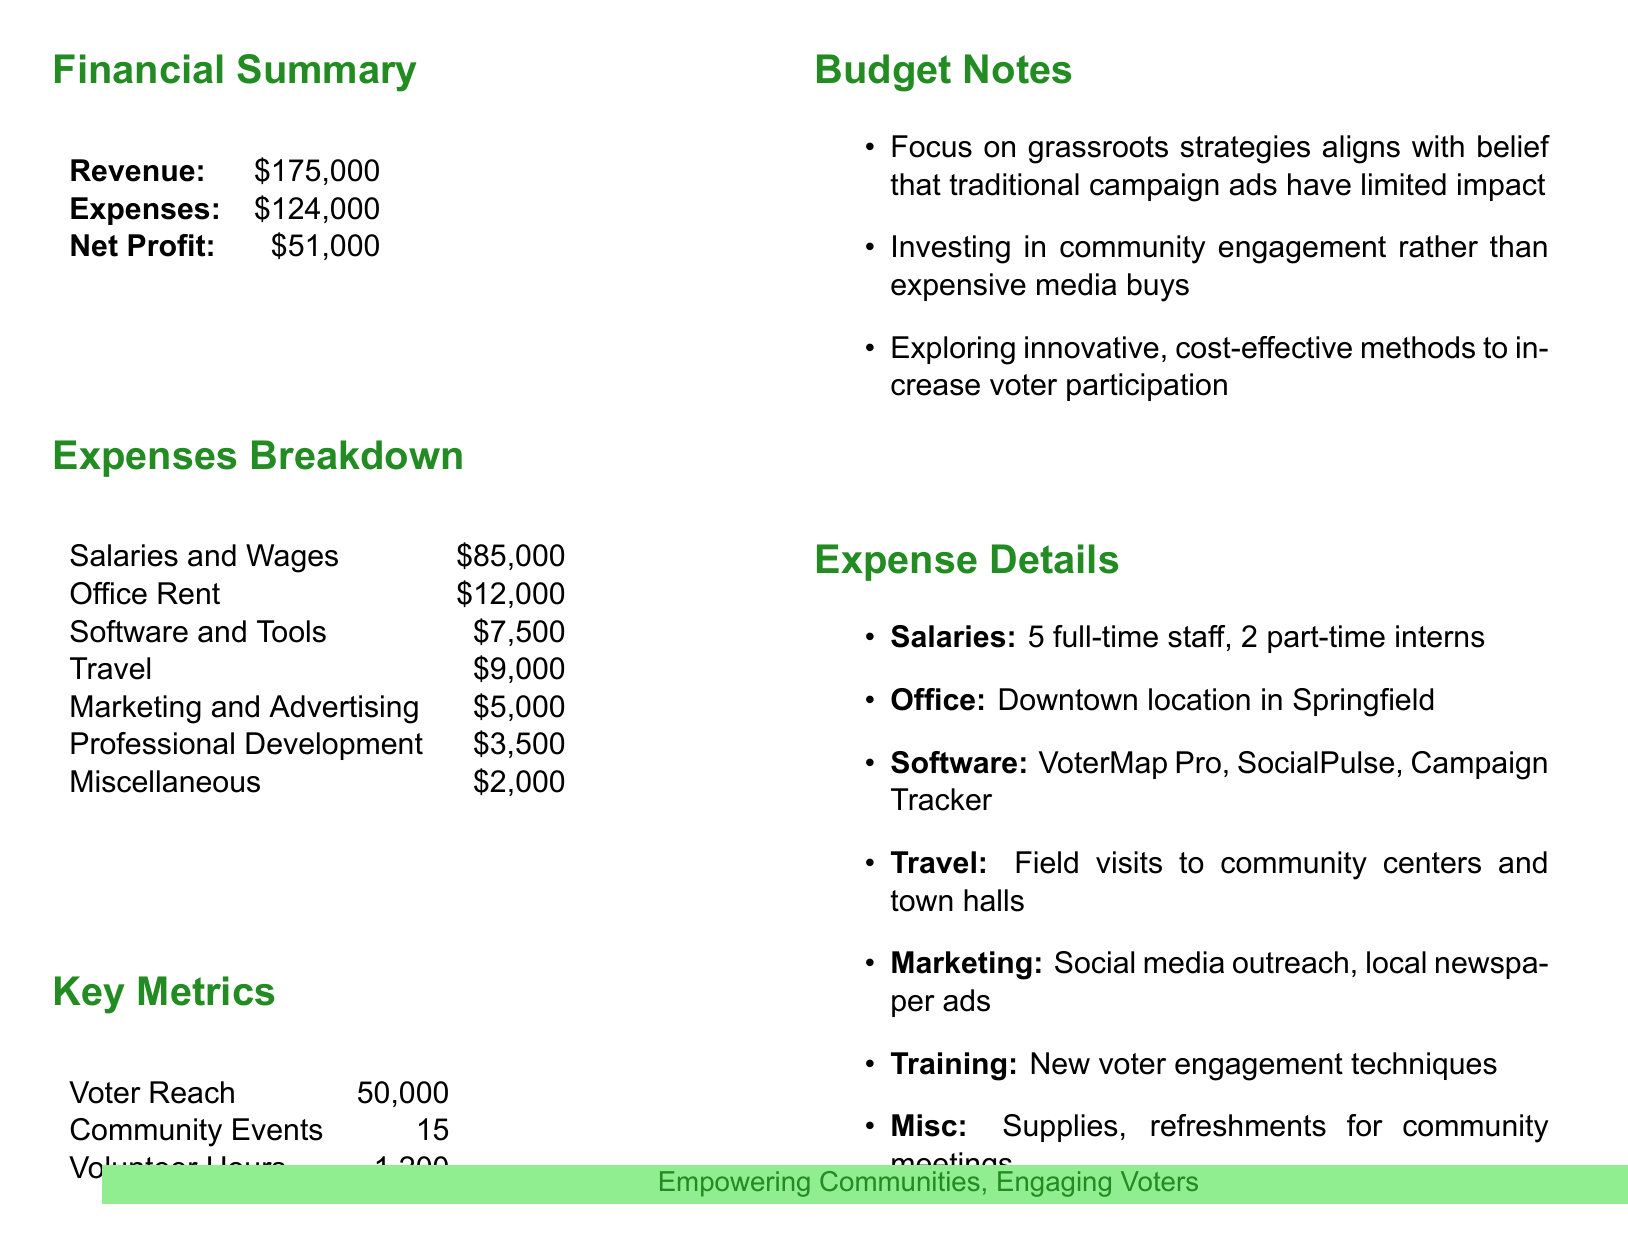What is the total revenue? The total revenue is explicitly stated in the financial summary section of the document as $175,000.
Answer: $175,000 What is the net profit? The net profit is calculated as revenue minus expenses, directly provided in the financial summary as $51,000.
Answer: $51,000 How much is allocated to salaries and wages? Salaries and wages total is listed under the expenses breakdown section as $85,000.
Answer: $85,000 What is the voter reach? The number of voters reached is stated in the key metrics section as 50,000.
Answer: 50,000 What is the amount spent on marketing and advertising? The expenses on marketing and advertising are shown in the breakdown section as $5,000.
Answer: $5,000 Why is the budget focused on grassroots strategies? The budget notes mention a focus on grassroots strategies because they align with the belief that traditional campaign ads have limited impact.
Answer: Limited impact of campaign ads What is the total amount spent on office rent? The amount allocated for office rent is specified in the expenses breakdown as $12,000.
Answer: $12,000 How many community events were organized? The number of community events is noted in the key metrics section as 15.
Answer: 15 What types of software are used? The software used, as listed in the expense details, includes VoterMap Pro, SocialPulse, and Campaign Tracker.
Answer: VoterMap Pro, SocialPulse, Campaign Tracker How many volunteer hours were logged? The total volunteer hours are provided in the key metrics section as 1,200.
Answer: 1,200 